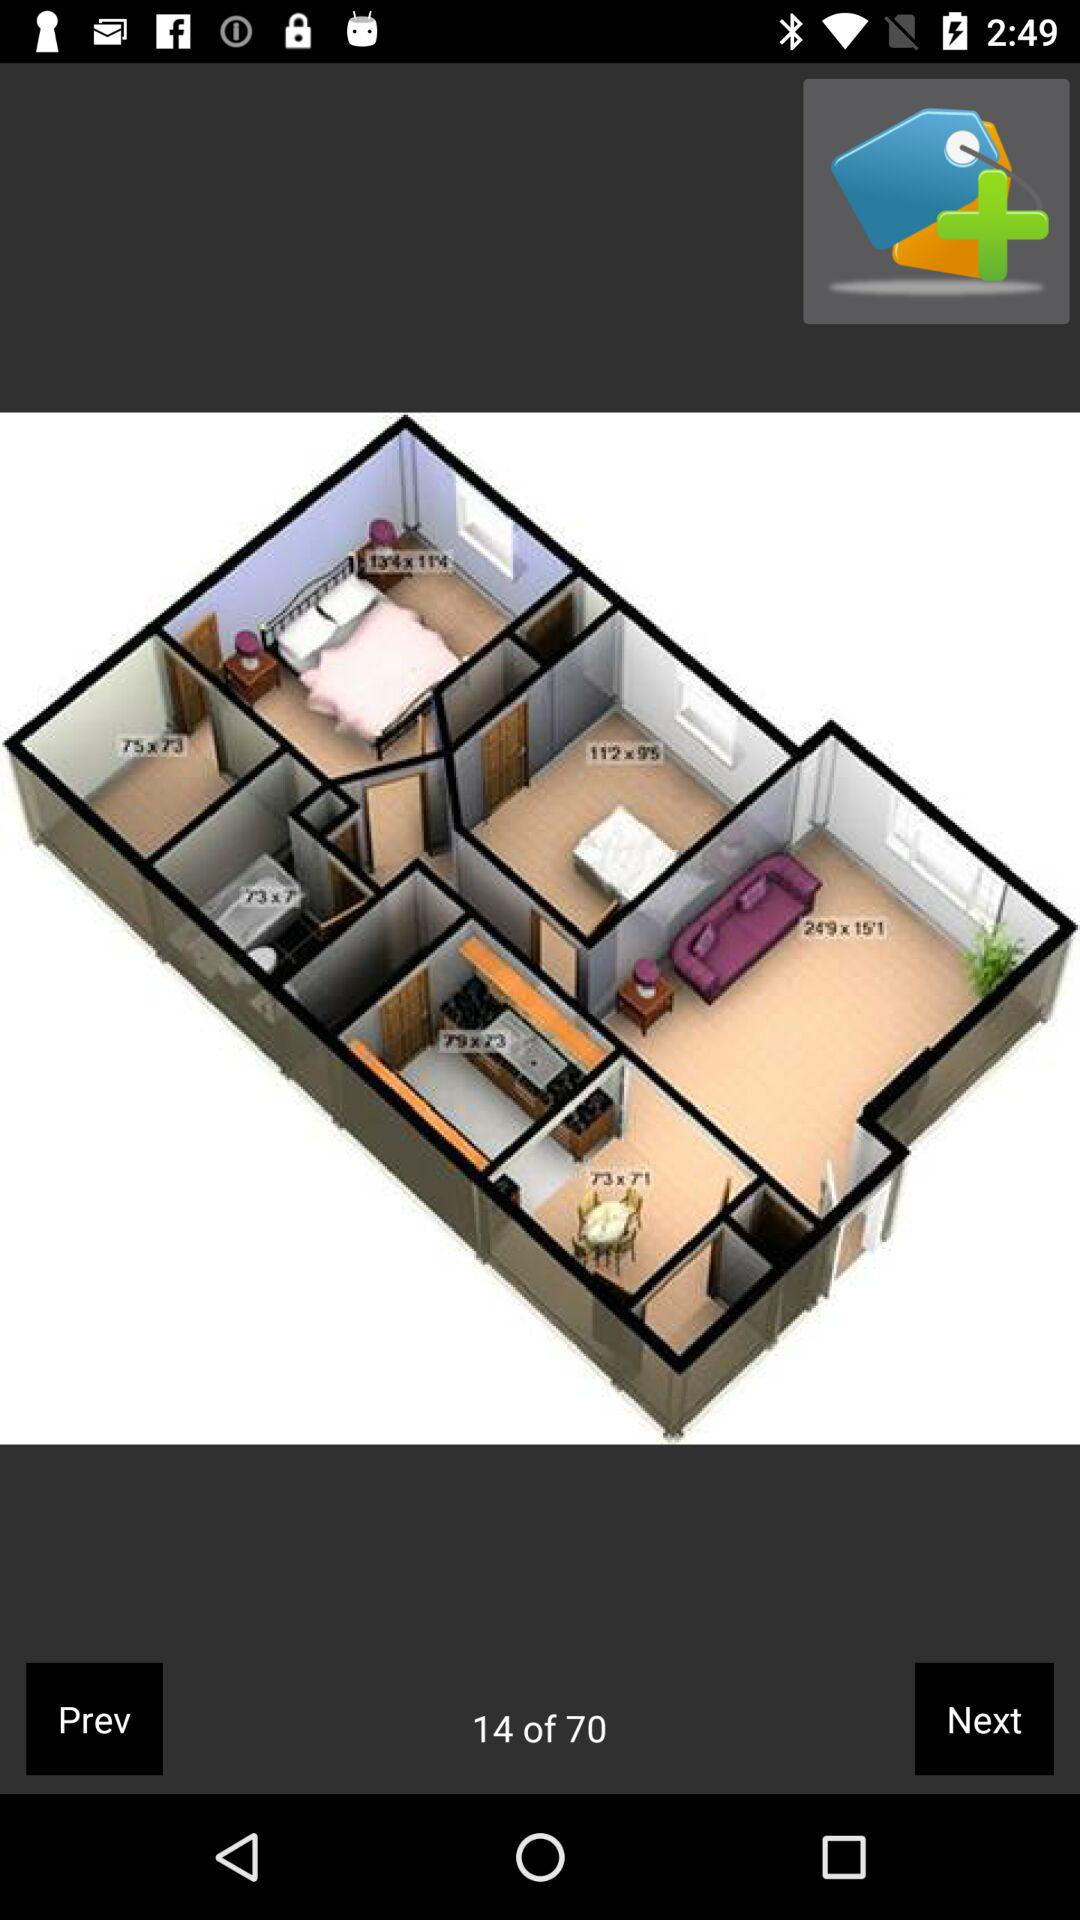How many more items are there than the current page?
Answer the question using a single word or phrase. 56 